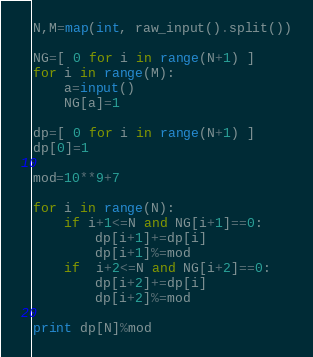<code> <loc_0><loc_0><loc_500><loc_500><_Python_>N,M=map(int, raw_input().split())

NG=[ 0 for i in range(N+1) ]
for i in range(M):
	a=input()
	NG[a]=1

dp=[ 0 for i in range(N+1) ]
dp[0]=1

mod=10**9+7

for i in range(N):
	if i+1<=N and NG[i+1]==0:
		dp[i+1]+=dp[i]
		dp[i+1]%=mod
	if  i+2<=N and NG[i+2]==0:
		dp[i+2]+=dp[i]
		dp[i+2]%=mod

print dp[N]%mod
</code> 